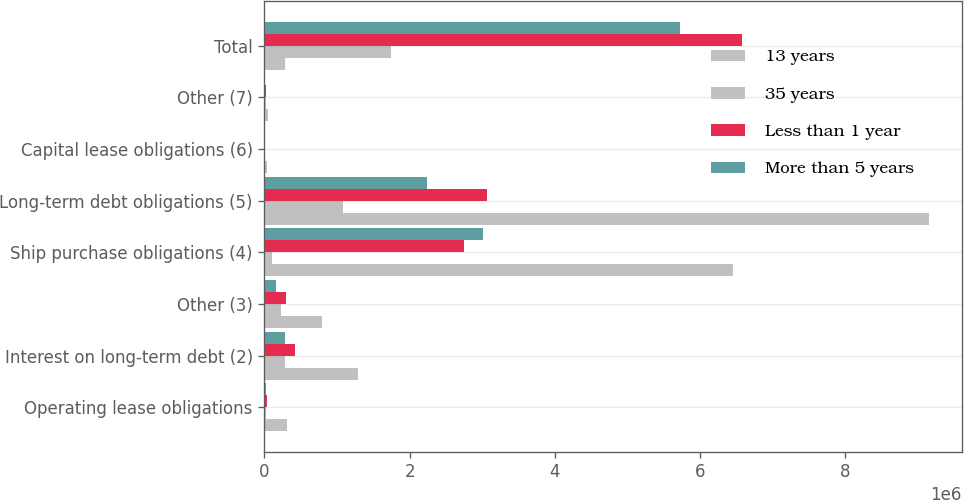<chart> <loc_0><loc_0><loc_500><loc_500><stacked_bar_chart><ecel><fcel>Operating lease obligations<fcel>Interest on long-term debt (2)<fcel>Other (3)<fcel>Ship purchase obligations (4)<fcel>Long-term debt obligations (5)<fcel>Capital lease obligations (6)<fcel>Other (7)<fcel>Total<nl><fcel>13 years<fcel>309797<fcel>1.29443e+06<fcel>795247<fcel>6.45415e+06<fcel>9.14705e+06<fcel>40384<fcel>51744<fcel>281066<nl><fcel>35 years<fcel>20749<fcel>281066<fcel>232055<fcel>108084<fcel>1.07872e+06<fcel>7016<fcel>18364<fcel>1.74605e+06<nl><fcel>Less than 1 year<fcel>33025<fcel>416711<fcel>292353<fcel>2.74636e+06<fcel>3.05742e+06<fcel>7031<fcel>25286<fcel>6.57818e+06<nl><fcel>More than 5 years<fcel>24135<fcel>277028<fcel>160520<fcel>3.00599e+06<fcel>2.23305e+06<fcel>8060<fcel>7805<fcel>5.71659e+06<nl></chart> 